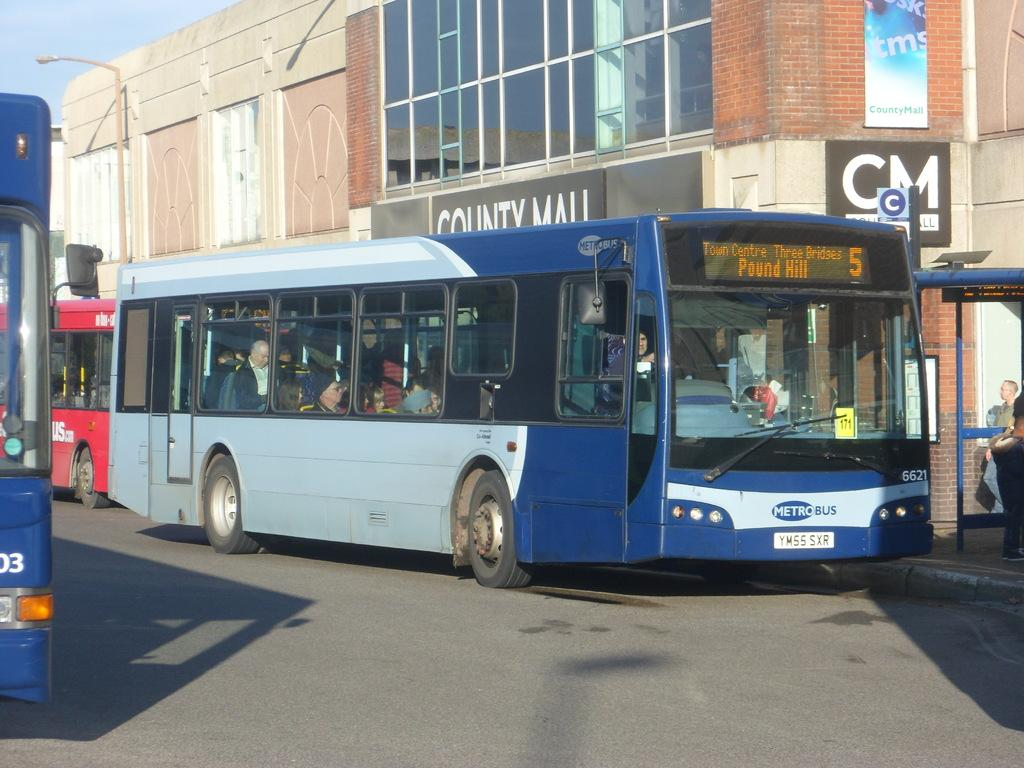<image>
Render a clear and concise summary of the photo. A Metro bus is driving past the County Mall building. 